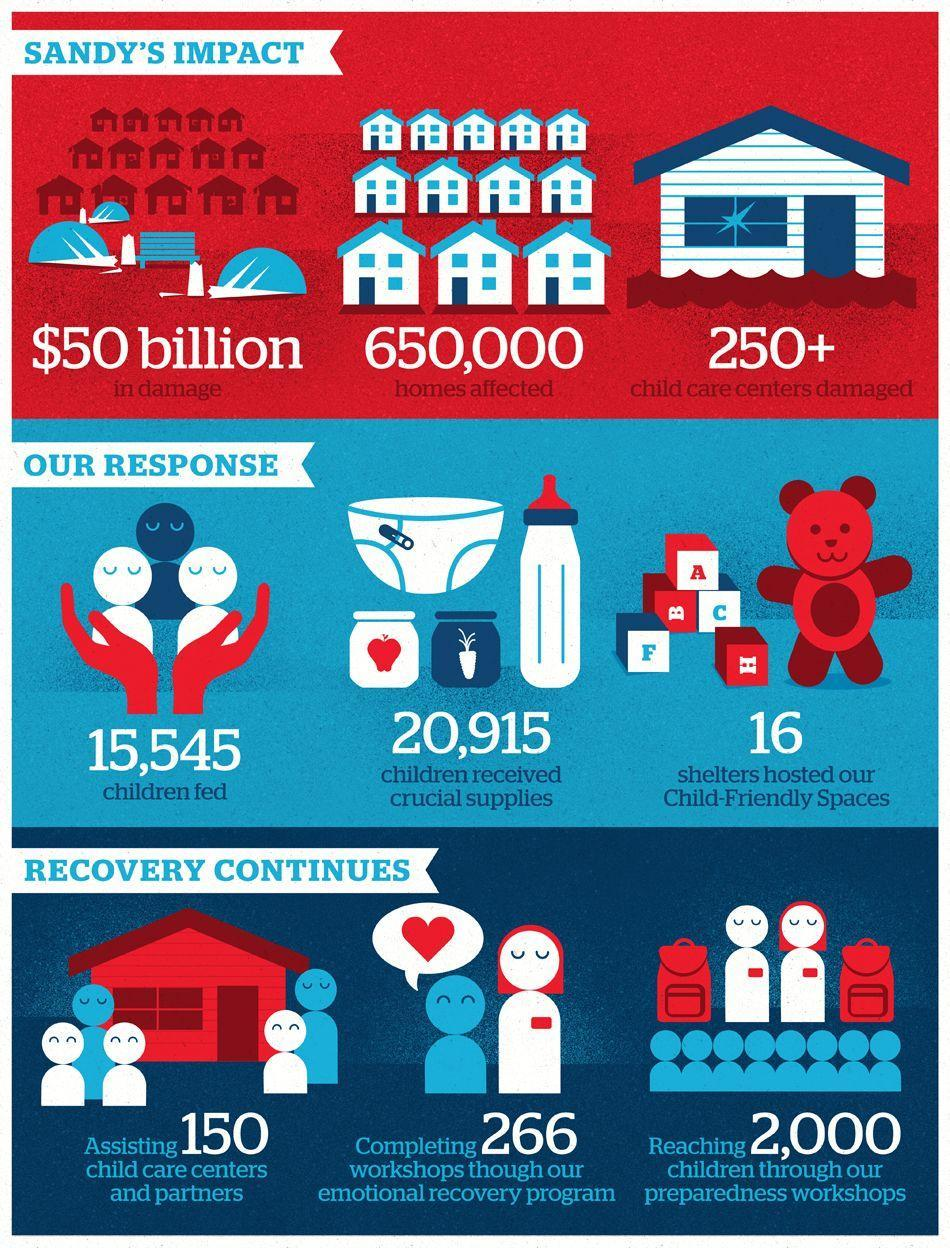How many child care centers were damaged by sandy hurricane?
Answer the question with a short phrase. 250+ How many workshops were completed as a part of emotional recovery program? 266 How many homes were affected by the sandy hurricane? 650,000 How much does the damage costs due to sandy's impact? $50 billion How many children affected by the sandy hurricane received crucial supplies? 20,915 